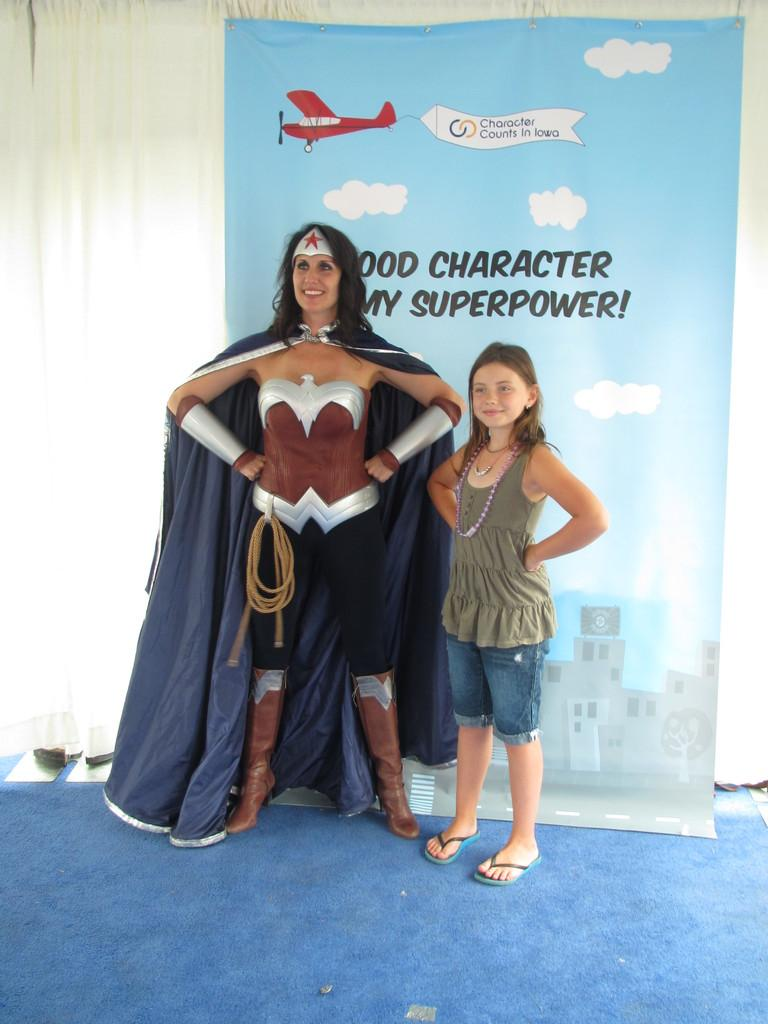Provide a one-sentence caption for the provided image. A woman in a super hero costume standing next to a girl with superpower over her head. 